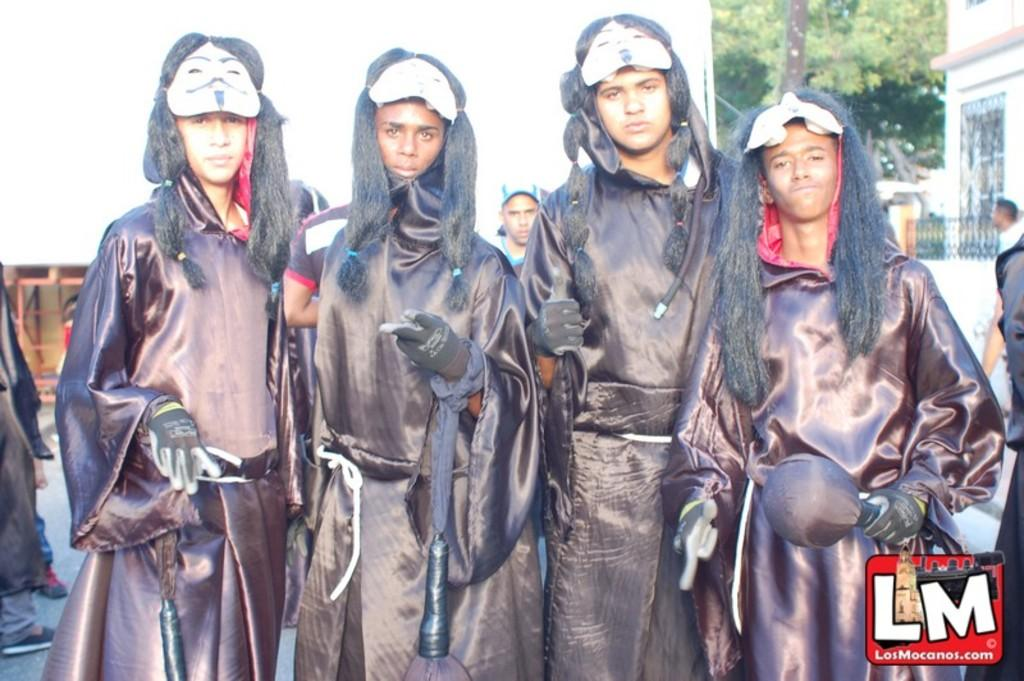Who or what can be seen in the image? There are people in the image. What is the color of the wall in the image? There is a white color wall in the image. What type of structure is present in the image? There is a building in the image. What is the entrance to the building like in the image? There is a gate in the image. What type of vegetation is visible in the image? There are trees in the image. What type of cork can be seen on the trees in the image? There is no cork present on the trees in the image. What season is depicted in the image, considering the presence of trees? The provided facts do not give enough information to determine the season depicted in the image. 